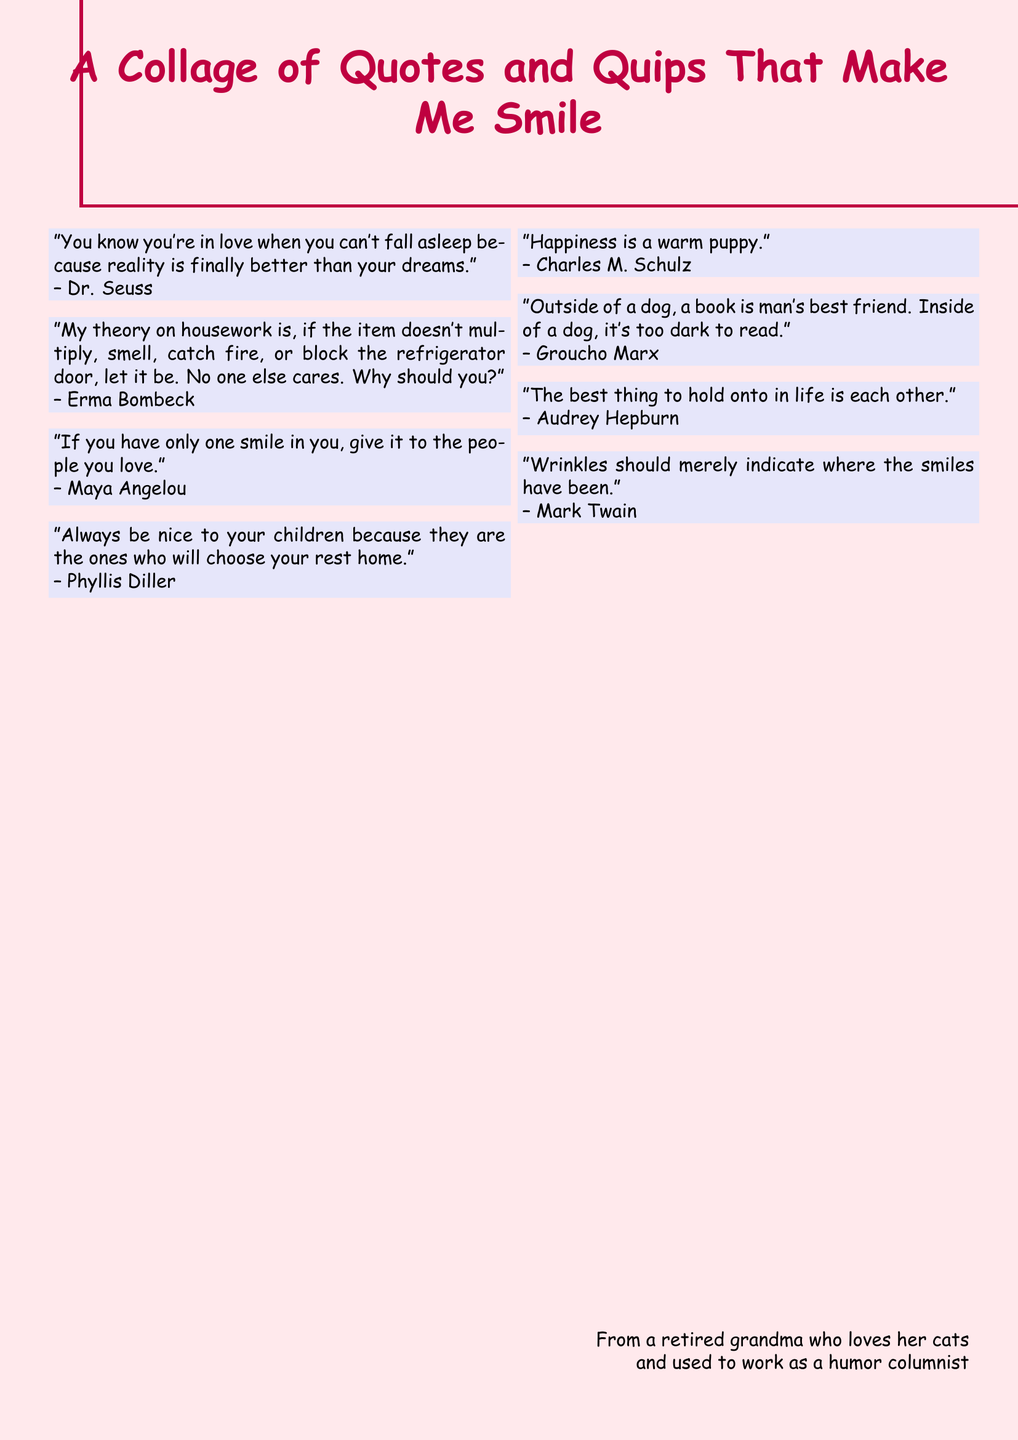What is the title of the document? The title is prominently displayed at the top of the document in a colorful font.
Answer: A Collage of Quotes and Quips That Make Me Smile Who is the quote by about love and dreams? The quote discusses love and dreams and is attributed to a well-known children's author.
Answer: Dr. Seuss What is Erma Bombeck's theory on housework? This theory suggests a humorous take on housework duties, highlighting certain specific conditions under which it should be ignored.
Answer: If the item doesn't multiply, smell, catch fire, or block the refrigerator door, let it be What is a warm puppy associated with? The quote links warmth and companionship in a light-hearted manner to pets, specifically dogs.
Answer: Happiness Who said, "Wrinkles should merely indicate where the smiles have been"? This quote reflects on aging with humor and is credited to a famous American author.
Answer: Mark Twain Which author emphasized the importance of smiling at loved ones? This author suggests that one should share their smile with those they love, highlighting the value of affection.
Answer: Maya Angelou What does the document reference about children and rest homes? This quote humorously suggests a motivation for being nice to children based on future consequences.
Answer: Always be nice to your children because they are the ones who will choose your rest home Who is credited for the quote about holding onto each other in life? The quote focuses on love and togetherness and is attributed to a film and fashion icon.
Answer: Audrey Hepburn 